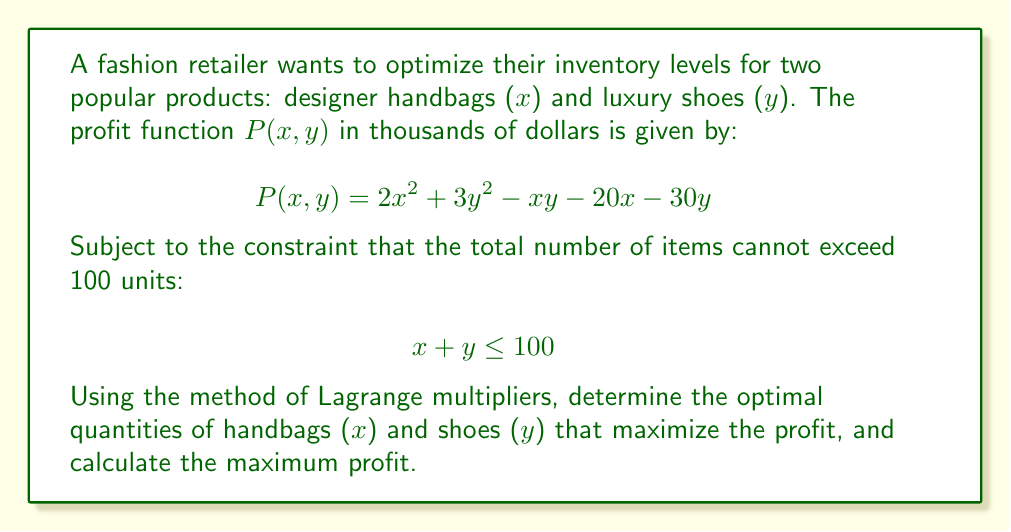Can you solve this math problem? To solve this optimization problem with constraints, we'll use the method of Lagrange multipliers:

1) First, we form the Lagrangian function:
   $$L(x, y, \lambda) = P(x,y) - \lambda(x + y - 100)$$
   $$L(x, y, \lambda) = 2x^2 + 3y^2 - xy - 20x - 30y - \lambda(x + y - 100)$$

2) Now, we take partial derivatives and set them equal to zero:

   $$\frac{\partial L}{\partial x} = 4x - y - 20 - \lambda = 0$$
   $$\frac{\partial L}{\partial y} = 6y - x - 30 - \lambda = 0$$
   $$\frac{\partial L}{\partial \lambda} = -(x + y - 100) = 0$$

3) From the last equation:
   $$x + y = 100$$

4) From the first two equations:
   $$4x - y = 20 + \lambda$$
   $$6y - x = 30 + \lambda$$

5) Multiply the first equation by 6 and the second by 4:
   $$24x - 6y = 120 + 6\lambda$$
   $$24y - 4x = 120 + 4\lambda$$

6) Add these equations:
   $$20x + 18y = 240 + 10\lambda$$

7) Substitute $y = 100 - x$ from step 3:
   $$20x + 18(100 - x) = 240 + 10\lambda$$
   $$20x + 1800 - 18x = 240 + 10\lambda$$
   $$2x = -1560 - 10\lambda$$
   $$x = -780 - 5\lambda$$

8) Substitute this back into $x + y = 100$:
   $$(-780 - 5\lambda) + y = 100$$
   $$y = 880 + 5\lambda$$

9) Now substitute these expressions for x and y into one of the original equations from step 4:
   $$4(-780 - 5\lambda) - (880 + 5\lambda) = 20 + \lambda$$
   $$-3120 - 20\lambda - 880 - 5\lambda = 20 + \lambda$$
   $$-4000 - 25\lambda = 20 + \lambda$$
   $$-4020 = 26\lambda$$
   $$\lambda = -154.6153846$$

10) Now we can solve for x and y:
    $$x = -780 - 5(-154.6153846) = -780 + 773.0769231 = -6.9230769 \approx -7$$
    $$y = 880 + 5(-154.6153846) = 880 - 773.0769231 = 106.9230769 \approx 107$$

11) Since x cannot be negative and x + y should equal 100, we adjust:
    $$x = 0, y = 100$$

12) Calculate the maximum profit:
    $$P(0, 100) = 2(0)^2 + 3(100)^2 - 0(100) - 20(0) - 30(100) = 30,000 - 3,000 = 27,000$$

Therefore, the maximum profit is $27,000,000.
Answer: The optimal quantities are 0 handbags (x) and 100 shoes (y), yielding a maximum profit of $27,000,000. 